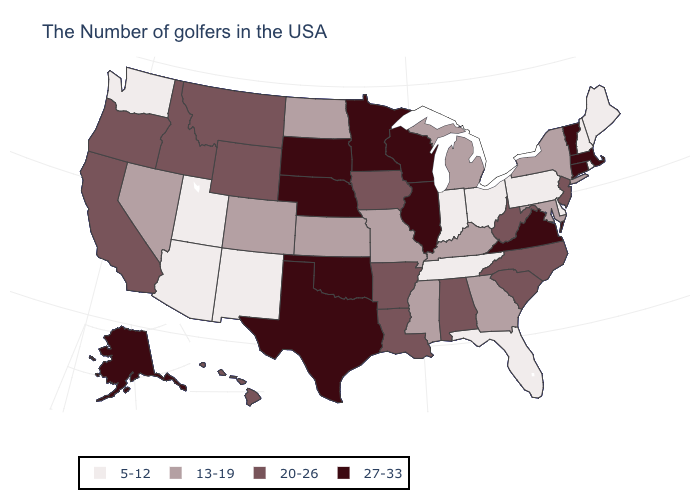Name the states that have a value in the range 5-12?
Write a very short answer. Maine, Rhode Island, New Hampshire, Delaware, Pennsylvania, Ohio, Florida, Indiana, Tennessee, New Mexico, Utah, Arizona, Washington. Is the legend a continuous bar?
Write a very short answer. No. Name the states that have a value in the range 27-33?
Answer briefly. Massachusetts, Vermont, Connecticut, Virginia, Wisconsin, Illinois, Minnesota, Nebraska, Oklahoma, Texas, South Dakota, Alaska. Name the states that have a value in the range 27-33?
Be succinct. Massachusetts, Vermont, Connecticut, Virginia, Wisconsin, Illinois, Minnesota, Nebraska, Oklahoma, Texas, South Dakota, Alaska. Which states have the lowest value in the West?
Answer briefly. New Mexico, Utah, Arizona, Washington. Among the states that border Nebraska , which have the highest value?
Quick response, please. South Dakota. Does New Mexico have the lowest value in the West?
Give a very brief answer. Yes. What is the lowest value in the USA?
Write a very short answer. 5-12. Which states have the highest value in the USA?
Answer briefly. Massachusetts, Vermont, Connecticut, Virginia, Wisconsin, Illinois, Minnesota, Nebraska, Oklahoma, Texas, South Dakota, Alaska. What is the value of Rhode Island?
Quick response, please. 5-12. Does Virginia have the lowest value in the USA?
Quick response, please. No. Among the states that border Ohio , does Indiana have the lowest value?
Give a very brief answer. Yes. Name the states that have a value in the range 27-33?
Short answer required. Massachusetts, Vermont, Connecticut, Virginia, Wisconsin, Illinois, Minnesota, Nebraska, Oklahoma, Texas, South Dakota, Alaska. Name the states that have a value in the range 5-12?
Quick response, please. Maine, Rhode Island, New Hampshire, Delaware, Pennsylvania, Ohio, Florida, Indiana, Tennessee, New Mexico, Utah, Arizona, Washington. Does the map have missing data?
Answer briefly. No. 